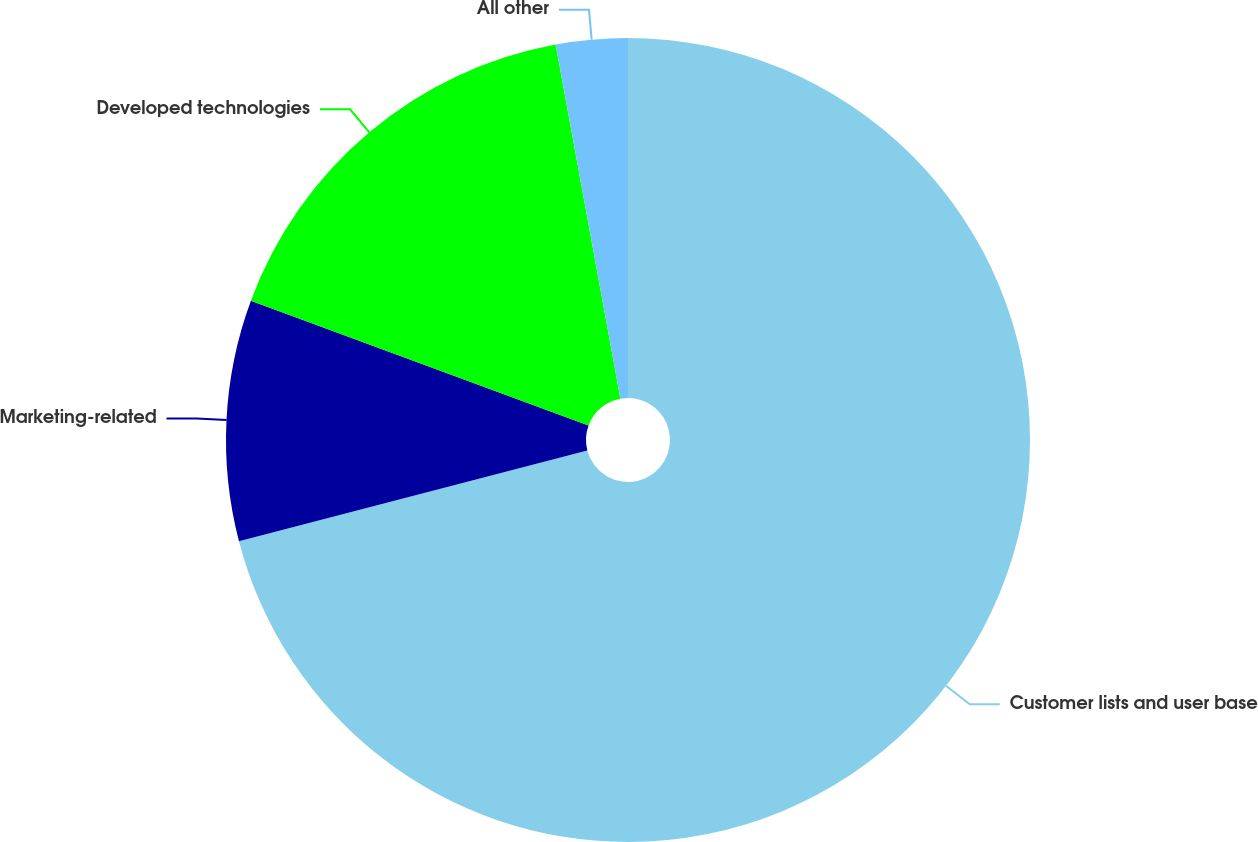Convert chart to OTSL. <chart><loc_0><loc_0><loc_500><loc_500><pie_chart><fcel>Customer lists and user base<fcel>Marketing-related<fcel>Developed technologies<fcel>All other<nl><fcel>70.95%<fcel>9.68%<fcel>16.49%<fcel>2.88%<nl></chart> 